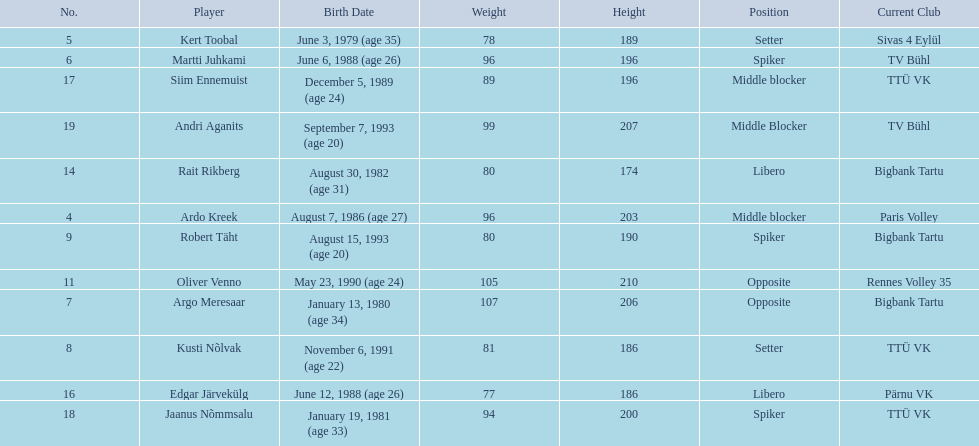Who are the players of the estonian men's national volleyball team? Ardo Kreek, Kert Toobal, Martti Juhkami, Argo Meresaar, Kusti Nõlvak, Robert Täht, Oliver Venno, Rait Rikberg, Edgar Järvekülg, Siim Ennemuist, Jaanus Nõmmsalu, Andri Aganits. Of these, which have a height over 200? Ardo Kreek, Argo Meresaar, Oliver Venno, Andri Aganits. Of the remaining, who is the tallest? Oliver Venno. 